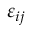Convert formula to latex. <formula><loc_0><loc_0><loc_500><loc_500>\varepsilon _ { i j }</formula> 